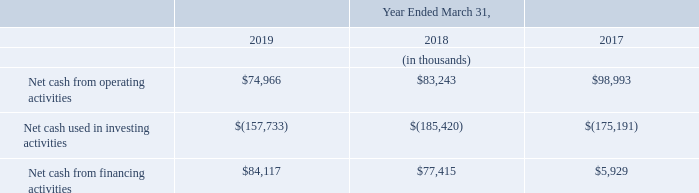Sources and uses of cash
Cash flow movement for the year ended March 31, 2019 compared to year ended March 31, 2018
Net cash generated from operating activities in fiscal year 2019 was $75.0 million compared to $83.2 million in the in fiscal year 2018, a decrease of $8.2 million, or 9.9%, primarily due to decrease in working capital movement of $65.1 million, mainly attributable to increase in trade receivables by $88.5 million and increase in trade payables by $23.4 million and as a result of lower operating profit before exceptional item generated in fiscal year 2019 as compared to fiscal year 2018.
Net cash used in investing activities in fiscal year 2019 was $157.7 million compared to $185.4 million in fiscal year 2018, a decrease of $27.7 million, or 14.9%, primarily as a result of investment in restricted deposits amounting to $53.5 million in fiscal year 2019 and offset by the decrease in purchase of intangible film rights and content rights in fiscal year 2019 was $107.7 million, compared to $186.8 million in fiscal year 2018, decrease of $79.1 million, or 42.3%.
Net cash from financing activities in fiscal year 2019 was $84.1 million compared to $77.4 million in fiscal year 2018, an increase of $6.7 million, or 8.7%, primarily as a result of the proceeds from the issuance of share capital and an increase in short-term borrowings in fiscal year, 2019.
Cash flow movement for the year ended March 31, 2018 compared to year ended March 31, 2017
Net cash generated from operating activities in fiscal year 2018, was $83.2 million, compared to $99.0 million in fiscal year 2017, a decrease of $15.8 million, or 15.9%, primarily due to decrease in working capital movement of $24.3 million mainly attributable to increase in trade receivables to $19.1 million and decrease in trade payables by $5.4 million. The cash flow from operating activities has also decreased due to increase in interest and income tax paid in fiscal 2018 by 2.4 million and $2.9 million respectively. The aforesaid decrease is partially offset on account of deconsolidation of a subsidiary during the year.
Net cash used in investing activities in fiscal year 2018 was $185.4 million, compared to $175.2 million in fiscal year 2017, an increase of $10.2 million, or 5.8%, due to the change in mix of films released in fiscal year 2018. The purchase of intangible film rights and content rights in fiscal year 2018 was $186.8 million, compared to $173.5 million in fiscal year 2017, an increase of $13.3 million, or 7.7%.
Net cash generated from financing activities in fiscal year 2018 was $77.4 million, compared to $5.9 million in fiscal year 2017, an increase of $71.5 million, or 1,205.7%, primarily due proceeds from issue of share capital of $16.6 million, proceeds from sale of shares of a subsidiary of $40.2 million and share application money of 18.0 million.
Capital expenditures
In fiscal year 2019, the company invested over $264.3 million (of which cash outflow is $107.7 million) in film content, and in fiscal 2020 the company expects to invest approximately $150 to $160 million in film content.
What is the  Net cash from operating activities for 2017, 2018 and 2019 respectively?
Answer scale should be: thousand. $98,993, $83,243, $74,966. What was the reason for decrease in net cash generated from operating activities in 2019? Primarily due to decrease in working capital movement of $65.1 million, mainly attributable to increase in trade receivables by $88.5 million and increase in trade payables by $23.4 million and as a result of lower operating profit before exceptional item generated in fiscal year 2019 as compared to fiscal year 2018. What was the net cash increase in financing activities? $6.7 million. Which year(s) had a  Net cash from financing activities greater than $70,000 thousand? At row 6 find the years that had  net cash from financing activities >70,000
answer: 2018, 2019. What is the average annual Net cash used in investing activities for 2017-2019?
Answer scale should be: thousand. -(157,733 + 185,420 + 175,191) / 3
Answer: -172781.33. What is the percentage increase / (decrease) in the net cash from financing activities from 2018 to 2019?
Answer scale should be: percent. 84,117 / 77,415 - 1
Answer: 8.66. 